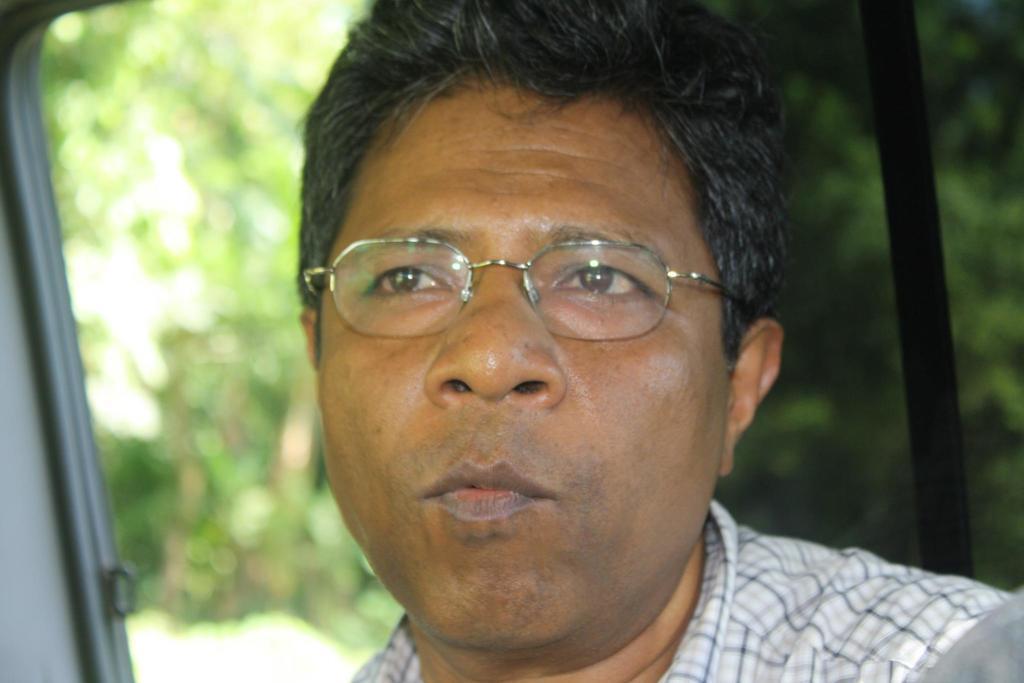In one or two sentences, can you explain what this image depicts? In this picture there is a man who is wearing shirt and spectacle. He is sitting inside the car. Back side of him we can see the window. Through the window we can see many trees and plants. 